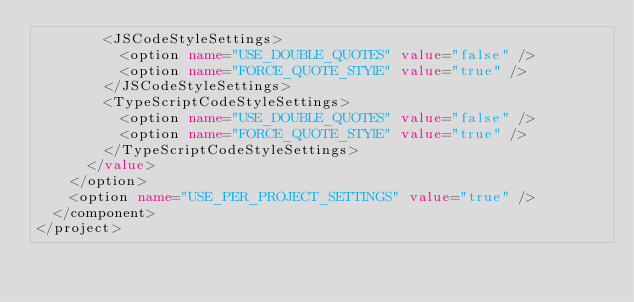<code> <loc_0><loc_0><loc_500><loc_500><_XML_>        <JSCodeStyleSettings>
          <option name="USE_DOUBLE_QUOTES" value="false" />
          <option name="FORCE_QUOTE_STYlE" value="true" />
        </JSCodeStyleSettings>
        <TypeScriptCodeStyleSettings>
          <option name="USE_DOUBLE_QUOTES" value="false" />
          <option name="FORCE_QUOTE_STYlE" value="true" />
        </TypeScriptCodeStyleSettings>
      </value>
    </option>
    <option name="USE_PER_PROJECT_SETTINGS" value="true" />
  </component>
</project></code> 